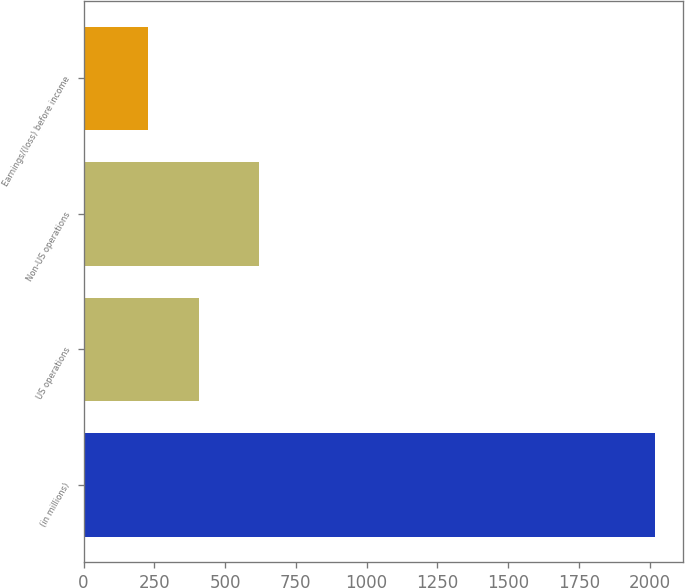<chart> <loc_0><loc_0><loc_500><loc_500><bar_chart><fcel>(in millions)<fcel>US operations<fcel>Non-US operations<fcel>Earnings/(loss) before income<nl><fcel>2018<fcel>407<fcel>619<fcel>228<nl></chart> 